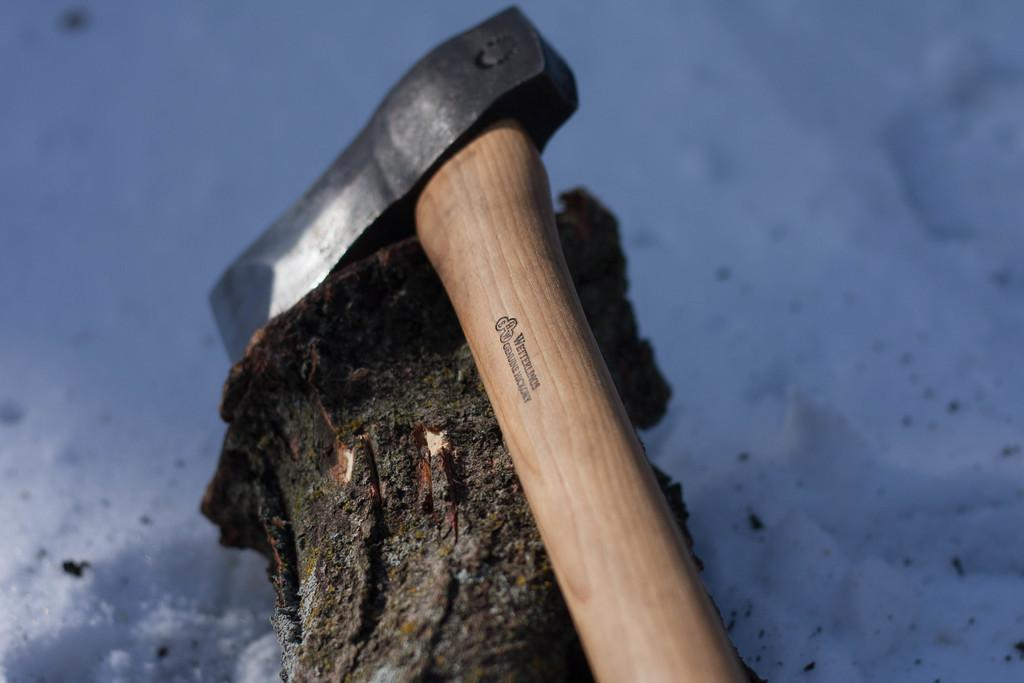What object can be seen in the image that is typically used for chopping wood? There is an axe in the image that is typically used for chopping wood. What colors can be observed on the axe in the image? The axe has brown, cream, and black colors. What is the wooden object in the image that the axe might be used on? There is a wooden log in the image that the axe might be used on. What colors can be observed on the wooden log in the image? The wooden log has black and brown colors. What type of weather condition is depicted in the image? The image shows snow. Where is the badge located on the wooden log in the image? There is no badge present on the wooden log or in the image. What direction does the base of the axe need to turn in order to chop the wooden log? The image does not show the axe in motion, so it is not possible to determine the direction it needs to turn. 